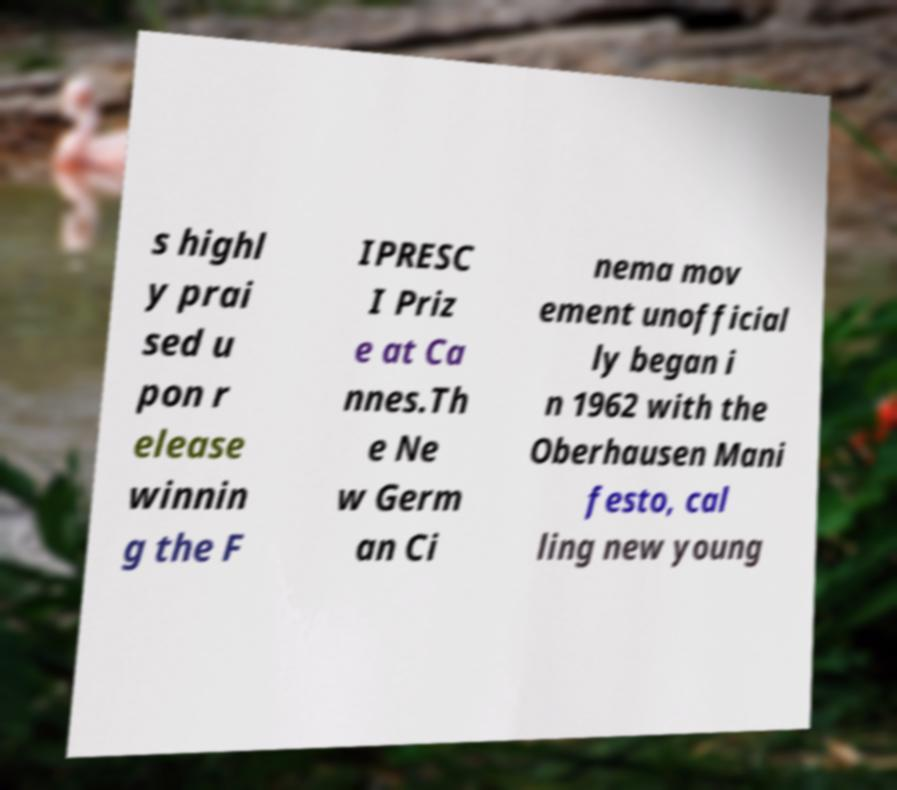Please identify and transcribe the text found in this image. s highl y prai sed u pon r elease winnin g the F IPRESC I Priz e at Ca nnes.Th e Ne w Germ an Ci nema mov ement unofficial ly began i n 1962 with the Oberhausen Mani festo, cal ling new young 